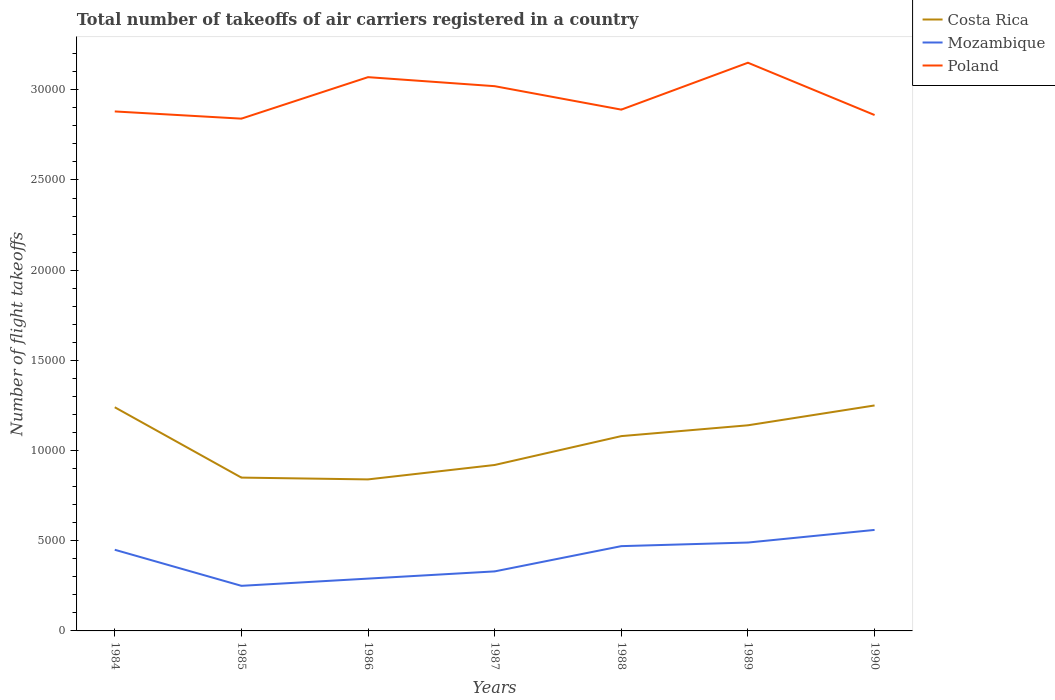Does the line corresponding to Poland intersect with the line corresponding to Mozambique?
Give a very brief answer. No. Is the number of lines equal to the number of legend labels?
Ensure brevity in your answer.  Yes. Across all years, what is the maximum total number of flight takeoffs in Costa Rica?
Give a very brief answer. 8400. In which year was the total number of flight takeoffs in Poland maximum?
Provide a short and direct response. 1985. What is the total total number of flight takeoffs in Costa Rica in the graph?
Offer a terse response. -4100. What is the difference between the highest and the second highest total number of flight takeoffs in Costa Rica?
Give a very brief answer. 4100. Is the total number of flight takeoffs in Mozambique strictly greater than the total number of flight takeoffs in Poland over the years?
Provide a succinct answer. Yes. How many years are there in the graph?
Your answer should be very brief. 7. Does the graph contain grids?
Your answer should be very brief. No. Where does the legend appear in the graph?
Offer a very short reply. Top right. What is the title of the graph?
Ensure brevity in your answer.  Total number of takeoffs of air carriers registered in a country. Does "Kazakhstan" appear as one of the legend labels in the graph?
Your answer should be very brief. No. What is the label or title of the Y-axis?
Ensure brevity in your answer.  Number of flight takeoffs. What is the Number of flight takeoffs of Costa Rica in 1984?
Offer a terse response. 1.24e+04. What is the Number of flight takeoffs in Mozambique in 1984?
Your response must be concise. 4500. What is the Number of flight takeoffs of Poland in 1984?
Provide a short and direct response. 2.88e+04. What is the Number of flight takeoffs in Costa Rica in 1985?
Make the answer very short. 8500. What is the Number of flight takeoffs in Mozambique in 1985?
Ensure brevity in your answer.  2500. What is the Number of flight takeoffs in Poland in 1985?
Your answer should be compact. 2.84e+04. What is the Number of flight takeoffs in Costa Rica in 1986?
Keep it short and to the point. 8400. What is the Number of flight takeoffs of Mozambique in 1986?
Your response must be concise. 2900. What is the Number of flight takeoffs in Poland in 1986?
Your answer should be compact. 3.07e+04. What is the Number of flight takeoffs of Costa Rica in 1987?
Offer a very short reply. 9200. What is the Number of flight takeoffs of Mozambique in 1987?
Your response must be concise. 3300. What is the Number of flight takeoffs in Poland in 1987?
Your answer should be compact. 3.02e+04. What is the Number of flight takeoffs in Costa Rica in 1988?
Provide a succinct answer. 1.08e+04. What is the Number of flight takeoffs of Mozambique in 1988?
Offer a terse response. 4700. What is the Number of flight takeoffs in Poland in 1988?
Your answer should be very brief. 2.89e+04. What is the Number of flight takeoffs in Costa Rica in 1989?
Offer a very short reply. 1.14e+04. What is the Number of flight takeoffs in Mozambique in 1989?
Your answer should be very brief. 4900. What is the Number of flight takeoffs of Poland in 1989?
Offer a terse response. 3.15e+04. What is the Number of flight takeoffs in Costa Rica in 1990?
Your answer should be very brief. 1.25e+04. What is the Number of flight takeoffs in Mozambique in 1990?
Keep it short and to the point. 5600. What is the Number of flight takeoffs of Poland in 1990?
Provide a short and direct response. 2.86e+04. Across all years, what is the maximum Number of flight takeoffs of Costa Rica?
Provide a short and direct response. 1.25e+04. Across all years, what is the maximum Number of flight takeoffs of Mozambique?
Your answer should be compact. 5600. Across all years, what is the maximum Number of flight takeoffs of Poland?
Ensure brevity in your answer.  3.15e+04. Across all years, what is the minimum Number of flight takeoffs of Costa Rica?
Keep it short and to the point. 8400. Across all years, what is the minimum Number of flight takeoffs in Mozambique?
Offer a terse response. 2500. Across all years, what is the minimum Number of flight takeoffs in Poland?
Provide a short and direct response. 2.84e+04. What is the total Number of flight takeoffs in Costa Rica in the graph?
Offer a terse response. 7.32e+04. What is the total Number of flight takeoffs of Mozambique in the graph?
Your answer should be compact. 2.84e+04. What is the total Number of flight takeoffs of Poland in the graph?
Offer a terse response. 2.07e+05. What is the difference between the Number of flight takeoffs of Costa Rica in 1984 and that in 1985?
Offer a terse response. 3900. What is the difference between the Number of flight takeoffs of Mozambique in 1984 and that in 1985?
Make the answer very short. 2000. What is the difference between the Number of flight takeoffs in Poland in 1984 and that in 1985?
Provide a short and direct response. 400. What is the difference between the Number of flight takeoffs of Costa Rica in 1984 and that in 1986?
Your answer should be compact. 4000. What is the difference between the Number of flight takeoffs of Mozambique in 1984 and that in 1986?
Provide a short and direct response. 1600. What is the difference between the Number of flight takeoffs in Poland in 1984 and that in 1986?
Offer a terse response. -1900. What is the difference between the Number of flight takeoffs in Costa Rica in 1984 and that in 1987?
Your answer should be very brief. 3200. What is the difference between the Number of flight takeoffs in Mozambique in 1984 and that in 1987?
Your response must be concise. 1200. What is the difference between the Number of flight takeoffs of Poland in 1984 and that in 1987?
Ensure brevity in your answer.  -1400. What is the difference between the Number of flight takeoffs in Costa Rica in 1984 and that in 1988?
Keep it short and to the point. 1600. What is the difference between the Number of flight takeoffs of Mozambique in 1984 and that in 1988?
Your answer should be very brief. -200. What is the difference between the Number of flight takeoffs of Poland in 1984 and that in 1988?
Keep it short and to the point. -100. What is the difference between the Number of flight takeoffs in Mozambique in 1984 and that in 1989?
Make the answer very short. -400. What is the difference between the Number of flight takeoffs of Poland in 1984 and that in 1989?
Keep it short and to the point. -2700. What is the difference between the Number of flight takeoffs of Costa Rica in 1984 and that in 1990?
Your answer should be very brief. -100. What is the difference between the Number of flight takeoffs of Mozambique in 1984 and that in 1990?
Provide a succinct answer. -1100. What is the difference between the Number of flight takeoffs in Poland in 1984 and that in 1990?
Provide a short and direct response. 200. What is the difference between the Number of flight takeoffs of Mozambique in 1985 and that in 1986?
Ensure brevity in your answer.  -400. What is the difference between the Number of flight takeoffs of Poland in 1985 and that in 1986?
Provide a succinct answer. -2300. What is the difference between the Number of flight takeoffs in Costa Rica in 1985 and that in 1987?
Your answer should be very brief. -700. What is the difference between the Number of flight takeoffs of Mozambique in 1985 and that in 1987?
Your answer should be compact. -800. What is the difference between the Number of flight takeoffs of Poland in 1985 and that in 1987?
Your response must be concise. -1800. What is the difference between the Number of flight takeoffs of Costa Rica in 1985 and that in 1988?
Offer a terse response. -2300. What is the difference between the Number of flight takeoffs of Mozambique in 1985 and that in 1988?
Offer a terse response. -2200. What is the difference between the Number of flight takeoffs of Poland in 1985 and that in 1988?
Give a very brief answer. -500. What is the difference between the Number of flight takeoffs of Costa Rica in 1985 and that in 1989?
Give a very brief answer. -2900. What is the difference between the Number of flight takeoffs in Mozambique in 1985 and that in 1989?
Your response must be concise. -2400. What is the difference between the Number of flight takeoffs in Poland in 1985 and that in 1989?
Ensure brevity in your answer.  -3100. What is the difference between the Number of flight takeoffs in Costa Rica in 1985 and that in 1990?
Your answer should be compact. -4000. What is the difference between the Number of flight takeoffs in Mozambique in 1985 and that in 1990?
Give a very brief answer. -3100. What is the difference between the Number of flight takeoffs of Poland in 1985 and that in 1990?
Offer a very short reply. -200. What is the difference between the Number of flight takeoffs in Costa Rica in 1986 and that in 1987?
Your response must be concise. -800. What is the difference between the Number of flight takeoffs of Mozambique in 1986 and that in 1987?
Offer a very short reply. -400. What is the difference between the Number of flight takeoffs of Costa Rica in 1986 and that in 1988?
Give a very brief answer. -2400. What is the difference between the Number of flight takeoffs in Mozambique in 1986 and that in 1988?
Make the answer very short. -1800. What is the difference between the Number of flight takeoffs in Poland in 1986 and that in 1988?
Provide a succinct answer. 1800. What is the difference between the Number of flight takeoffs in Costa Rica in 1986 and that in 1989?
Your answer should be very brief. -3000. What is the difference between the Number of flight takeoffs of Mozambique in 1986 and that in 1989?
Provide a succinct answer. -2000. What is the difference between the Number of flight takeoffs in Poland in 1986 and that in 1989?
Provide a short and direct response. -800. What is the difference between the Number of flight takeoffs in Costa Rica in 1986 and that in 1990?
Offer a very short reply. -4100. What is the difference between the Number of flight takeoffs in Mozambique in 1986 and that in 1990?
Provide a short and direct response. -2700. What is the difference between the Number of flight takeoffs of Poland in 1986 and that in 1990?
Provide a short and direct response. 2100. What is the difference between the Number of flight takeoffs of Costa Rica in 1987 and that in 1988?
Your answer should be compact. -1600. What is the difference between the Number of flight takeoffs of Mozambique in 1987 and that in 1988?
Ensure brevity in your answer.  -1400. What is the difference between the Number of flight takeoffs in Poland in 1987 and that in 1988?
Give a very brief answer. 1300. What is the difference between the Number of flight takeoffs of Costa Rica in 1987 and that in 1989?
Your response must be concise. -2200. What is the difference between the Number of flight takeoffs in Mozambique in 1987 and that in 1989?
Ensure brevity in your answer.  -1600. What is the difference between the Number of flight takeoffs in Poland in 1987 and that in 1989?
Your answer should be compact. -1300. What is the difference between the Number of flight takeoffs in Costa Rica in 1987 and that in 1990?
Your answer should be very brief. -3300. What is the difference between the Number of flight takeoffs of Mozambique in 1987 and that in 1990?
Provide a short and direct response. -2300. What is the difference between the Number of flight takeoffs in Poland in 1987 and that in 1990?
Offer a terse response. 1600. What is the difference between the Number of flight takeoffs of Costa Rica in 1988 and that in 1989?
Provide a short and direct response. -600. What is the difference between the Number of flight takeoffs of Mozambique in 1988 and that in 1989?
Offer a terse response. -200. What is the difference between the Number of flight takeoffs of Poland in 1988 and that in 1989?
Your answer should be compact. -2600. What is the difference between the Number of flight takeoffs in Costa Rica in 1988 and that in 1990?
Offer a terse response. -1700. What is the difference between the Number of flight takeoffs in Mozambique in 1988 and that in 1990?
Offer a terse response. -900. What is the difference between the Number of flight takeoffs of Poland in 1988 and that in 1990?
Make the answer very short. 300. What is the difference between the Number of flight takeoffs of Costa Rica in 1989 and that in 1990?
Your response must be concise. -1100. What is the difference between the Number of flight takeoffs in Mozambique in 1989 and that in 1990?
Offer a terse response. -700. What is the difference between the Number of flight takeoffs in Poland in 1989 and that in 1990?
Provide a short and direct response. 2900. What is the difference between the Number of flight takeoffs of Costa Rica in 1984 and the Number of flight takeoffs of Mozambique in 1985?
Your answer should be very brief. 9900. What is the difference between the Number of flight takeoffs in Costa Rica in 1984 and the Number of flight takeoffs in Poland in 1985?
Provide a short and direct response. -1.60e+04. What is the difference between the Number of flight takeoffs in Mozambique in 1984 and the Number of flight takeoffs in Poland in 1985?
Make the answer very short. -2.39e+04. What is the difference between the Number of flight takeoffs of Costa Rica in 1984 and the Number of flight takeoffs of Mozambique in 1986?
Provide a short and direct response. 9500. What is the difference between the Number of flight takeoffs in Costa Rica in 1984 and the Number of flight takeoffs in Poland in 1986?
Offer a very short reply. -1.83e+04. What is the difference between the Number of flight takeoffs in Mozambique in 1984 and the Number of flight takeoffs in Poland in 1986?
Offer a very short reply. -2.62e+04. What is the difference between the Number of flight takeoffs in Costa Rica in 1984 and the Number of flight takeoffs in Mozambique in 1987?
Keep it short and to the point. 9100. What is the difference between the Number of flight takeoffs in Costa Rica in 1984 and the Number of flight takeoffs in Poland in 1987?
Offer a very short reply. -1.78e+04. What is the difference between the Number of flight takeoffs of Mozambique in 1984 and the Number of flight takeoffs of Poland in 1987?
Your response must be concise. -2.57e+04. What is the difference between the Number of flight takeoffs of Costa Rica in 1984 and the Number of flight takeoffs of Mozambique in 1988?
Offer a very short reply. 7700. What is the difference between the Number of flight takeoffs of Costa Rica in 1984 and the Number of flight takeoffs of Poland in 1988?
Provide a short and direct response. -1.65e+04. What is the difference between the Number of flight takeoffs in Mozambique in 1984 and the Number of flight takeoffs in Poland in 1988?
Provide a short and direct response. -2.44e+04. What is the difference between the Number of flight takeoffs of Costa Rica in 1984 and the Number of flight takeoffs of Mozambique in 1989?
Offer a terse response. 7500. What is the difference between the Number of flight takeoffs of Costa Rica in 1984 and the Number of flight takeoffs of Poland in 1989?
Your answer should be compact. -1.91e+04. What is the difference between the Number of flight takeoffs in Mozambique in 1984 and the Number of flight takeoffs in Poland in 1989?
Your answer should be very brief. -2.70e+04. What is the difference between the Number of flight takeoffs of Costa Rica in 1984 and the Number of flight takeoffs of Mozambique in 1990?
Provide a short and direct response. 6800. What is the difference between the Number of flight takeoffs of Costa Rica in 1984 and the Number of flight takeoffs of Poland in 1990?
Offer a terse response. -1.62e+04. What is the difference between the Number of flight takeoffs of Mozambique in 1984 and the Number of flight takeoffs of Poland in 1990?
Provide a succinct answer. -2.41e+04. What is the difference between the Number of flight takeoffs in Costa Rica in 1985 and the Number of flight takeoffs in Mozambique in 1986?
Your answer should be very brief. 5600. What is the difference between the Number of flight takeoffs in Costa Rica in 1985 and the Number of flight takeoffs in Poland in 1986?
Make the answer very short. -2.22e+04. What is the difference between the Number of flight takeoffs in Mozambique in 1985 and the Number of flight takeoffs in Poland in 1986?
Offer a terse response. -2.82e+04. What is the difference between the Number of flight takeoffs in Costa Rica in 1985 and the Number of flight takeoffs in Mozambique in 1987?
Offer a very short reply. 5200. What is the difference between the Number of flight takeoffs in Costa Rica in 1985 and the Number of flight takeoffs in Poland in 1987?
Your answer should be very brief. -2.17e+04. What is the difference between the Number of flight takeoffs in Mozambique in 1985 and the Number of flight takeoffs in Poland in 1987?
Make the answer very short. -2.77e+04. What is the difference between the Number of flight takeoffs of Costa Rica in 1985 and the Number of flight takeoffs of Mozambique in 1988?
Your response must be concise. 3800. What is the difference between the Number of flight takeoffs of Costa Rica in 1985 and the Number of flight takeoffs of Poland in 1988?
Provide a short and direct response. -2.04e+04. What is the difference between the Number of flight takeoffs in Mozambique in 1985 and the Number of flight takeoffs in Poland in 1988?
Make the answer very short. -2.64e+04. What is the difference between the Number of flight takeoffs of Costa Rica in 1985 and the Number of flight takeoffs of Mozambique in 1989?
Your response must be concise. 3600. What is the difference between the Number of flight takeoffs of Costa Rica in 1985 and the Number of flight takeoffs of Poland in 1989?
Ensure brevity in your answer.  -2.30e+04. What is the difference between the Number of flight takeoffs of Mozambique in 1985 and the Number of flight takeoffs of Poland in 1989?
Your answer should be compact. -2.90e+04. What is the difference between the Number of flight takeoffs of Costa Rica in 1985 and the Number of flight takeoffs of Mozambique in 1990?
Provide a succinct answer. 2900. What is the difference between the Number of flight takeoffs in Costa Rica in 1985 and the Number of flight takeoffs in Poland in 1990?
Offer a terse response. -2.01e+04. What is the difference between the Number of flight takeoffs in Mozambique in 1985 and the Number of flight takeoffs in Poland in 1990?
Your answer should be compact. -2.61e+04. What is the difference between the Number of flight takeoffs of Costa Rica in 1986 and the Number of flight takeoffs of Mozambique in 1987?
Your answer should be very brief. 5100. What is the difference between the Number of flight takeoffs in Costa Rica in 1986 and the Number of flight takeoffs in Poland in 1987?
Offer a very short reply. -2.18e+04. What is the difference between the Number of flight takeoffs in Mozambique in 1986 and the Number of flight takeoffs in Poland in 1987?
Provide a short and direct response. -2.73e+04. What is the difference between the Number of flight takeoffs in Costa Rica in 1986 and the Number of flight takeoffs in Mozambique in 1988?
Make the answer very short. 3700. What is the difference between the Number of flight takeoffs of Costa Rica in 1986 and the Number of flight takeoffs of Poland in 1988?
Make the answer very short. -2.05e+04. What is the difference between the Number of flight takeoffs in Mozambique in 1986 and the Number of flight takeoffs in Poland in 1988?
Give a very brief answer. -2.60e+04. What is the difference between the Number of flight takeoffs in Costa Rica in 1986 and the Number of flight takeoffs in Mozambique in 1989?
Ensure brevity in your answer.  3500. What is the difference between the Number of flight takeoffs in Costa Rica in 1986 and the Number of flight takeoffs in Poland in 1989?
Offer a very short reply. -2.31e+04. What is the difference between the Number of flight takeoffs of Mozambique in 1986 and the Number of flight takeoffs of Poland in 1989?
Your response must be concise. -2.86e+04. What is the difference between the Number of flight takeoffs of Costa Rica in 1986 and the Number of flight takeoffs of Mozambique in 1990?
Ensure brevity in your answer.  2800. What is the difference between the Number of flight takeoffs of Costa Rica in 1986 and the Number of flight takeoffs of Poland in 1990?
Offer a very short reply. -2.02e+04. What is the difference between the Number of flight takeoffs in Mozambique in 1986 and the Number of flight takeoffs in Poland in 1990?
Give a very brief answer. -2.57e+04. What is the difference between the Number of flight takeoffs of Costa Rica in 1987 and the Number of flight takeoffs of Mozambique in 1988?
Give a very brief answer. 4500. What is the difference between the Number of flight takeoffs in Costa Rica in 1987 and the Number of flight takeoffs in Poland in 1988?
Offer a terse response. -1.97e+04. What is the difference between the Number of flight takeoffs of Mozambique in 1987 and the Number of flight takeoffs of Poland in 1988?
Your answer should be very brief. -2.56e+04. What is the difference between the Number of flight takeoffs in Costa Rica in 1987 and the Number of flight takeoffs in Mozambique in 1989?
Provide a succinct answer. 4300. What is the difference between the Number of flight takeoffs in Costa Rica in 1987 and the Number of flight takeoffs in Poland in 1989?
Offer a terse response. -2.23e+04. What is the difference between the Number of flight takeoffs of Mozambique in 1987 and the Number of flight takeoffs of Poland in 1989?
Provide a short and direct response. -2.82e+04. What is the difference between the Number of flight takeoffs of Costa Rica in 1987 and the Number of flight takeoffs of Mozambique in 1990?
Offer a very short reply. 3600. What is the difference between the Number of flight takeoffs in Costa Rica in 1987 and the Number of flight takeoffs in Poland in 1990?
Provide a succinct answer. -1.94e+04. What is the difference between the Number of flight takeoffs in Mozambique in 1987 and the Number of flight takeoffs in Poland in 1990?
Give a very brief answer. -2.53e+04. What is the difference between the Number of flight takeoffs of Costa Rica in 1988 and the Number of flight takeoffs of Mozambique in 1989?
Make the answer very short. 5900. What is the difference between the Number of flight takeoffs of Costa Rica in 1988 and the Number of flight takeoffs of Poland in 1989?
Give a very brief answer. -2.07e+04. What is the difference between the Number of flight takeoffs of Mozambique in 1988 and the Number of flight takeoffs of Poland in 1989?
Your response must be concise. -2.68e+04. What is the difference between the Number of flight takeoffs of Costa Rica in 1988 and the Number of flight takeoffs of Mozambique in 1990?
Offer a very short reply. 5200. What is the difference between the Number of flight takeoffs of Costa Rica in 1988 and the Number of flight takeoffs of Poland in 1990?
Your answer should be compact. -1.78e+04. What is the difference between the Number of flight takeoffs in Mozambique in 1988 and the Number of flight takeoffs in Poland in 1990?
Your answer should be very brief. -2.39e+04. What is the difference between the Number of flight takeoffs in Costa Rica in 1989 and the Number of flight takeoffs in Mozambique in 1990?
Offer a very short reply. 5800. What is the difference between the Number of flight takeoffs in Costa Rica in 1989 and the Number of flight takeoffs in Poland in 1990?
Your response must be concise. -1.72e+04. What is the difference between the Number of flight takeoffs of Mozambique in 1989 and the Number of flight takeoffs of Poland in 1990?
Offer a terse response. -2.37e+04. What is the average Number of flight takeoffs of Costa Rica per year?
Keep it short and to the point. 1.05e+04. What is the average Number of flight takeoffs of Mozambique per year?
Make the answer very short. 4057.14. What is the average Number of flight takeoffs in Poland per year?
Your answer should be compact. 2.96e+04. In the year 1984, what is the difference between the Number of flight takeoffs of Costa Rica and Number of flight takeoffs of Mozambique?
Your answer should be very brief. 7900. In the year 1984, what is the difference between the Number of flight takeoffs of Costa Rica and Number of flight takeoffs of Poland?
Provide a succinct answer. -1.64e+04. In the year 1984, what is the difference between the Number of flight takeoffs of Mozambique and Number of flight takeoffs of Poland?
Keep it short and to the point. -2.43e+04. In the year 1985, what is the difference between the Number of flight takeoffs in Costa Rica and Number of flight takeoffs in Mozambique?
Your answer should be very brief. 6000. In the year 1985, what is the difference between the Number of flight takeoffs of Costa Rica and Number of flight takeoffs of Poland?
Keep it short and to the point. -1.99e+04. In the year 1985, what is the difference between the Number of flight takeoffs of Mozambique and Number of flight takeoffs of Poland?
Offer a very short reply. -2.59e+04. In the year 1986, what is the difference between the Number of flight takeoffs of Costa Rica and Number of flight takeoffs of Mozambique?
Provide a succinct answer. 5500. In the year 1986, what is the difference between the Number of flight takeoffs of Costa Rica and Number of flight takeoffs of Poland?
Ensure brevity in your answer.  -2.23e+04. In the year 1986, what is the difference between the Number of flight takeoffs in Mozambique and Number of flight takeoffs in Poland?
Provide a short and direct response. -2.78e+04. In the year 1987, what is the difference between the Number of flight takeoffs in Costa Rica and Number of flight takeoffs in Mozambique?
Offer a very short reply. 5900. In the year 1987, what is the difference between the Number of flight takeoffs in Costa Rica and Number of flight takeoffs in Poland?
Provide a short and direct response. -2.10e+04. In the year 1987, what is the difference between the Number of flight takeoffs in Mozambique and Number of flight takeoffs in Poland?
Your answer should be compact. -2.69e+04. In the year 1988, what is the difference between the Number of flight takeoffs in Costa Rica and Number of flight takeoffs in Mozambique?
Make the answer very short. 6100. In the year 1988, what is the difference between the Number of flight takeoffs in Costa Rica and Number of flight takeoffs in Poland?
Keep it short and to the point. -1.81e+04. In the year 1988, what is the difference between the Number of flight takeoffs in Mozambique and Number of flight takeoffs in Poland?
Make the answer very short. -2.42e+04. In the year 1989, what is the difference between the Number of flight takeoffs in Costa Rica and Number of flight takeoffs in Mozambique?
Your answer should be very brief. 6500. In the year 1989, what is the difference between the Number of flight takeoffs of Costa Rica and Number of flight takeoffs of Poland?
Give a very brief answer. -2.01e+04. In the year 1989, what is the difference between the Number of flight takeoffs of Mozambique and Number of flight takeoffs of Poland?
Keep it short and to the point. -2.66e+04. In the year 1990, what is the difference between the Number of flight takeoffs of Costa Rica and Number of flight takeoffs of Mozambique?
Provide a short and direct response. 6900. In the year 1990, what is the difference between the Number of flight takeoffs in Costa Rica and Number of flight takeoffs in Poland?
Give a very brief answer. -1.61e+04. In the year 1990, what is the difference between the Number of flight takeoffs in Mozambique and Number of flight takeoffs in Poland?
Offer a terse response. -2.30e+04. What is the ratio of the Number of flight takeoffs in Costa Rica in 1984 to that in 1985?
Provide a succinct answer. 1.46. What is the ratio of the Number of flight takeoffs of Mozambique in 1984 to that in 1985?
Ensure brevity in your answer.  1.8. What is the ratio of the Number of flight takeoffs of Poland in 1984 to that in 1985?
Offer a terse response. 1.01. What is the ratio of the Number of flight takeoffs in Costa Rica in 1984 to that in 1986?
Keep it short and to the point. 1.48. What is the ratio of the Number of flight takeoffs of Mozambique in 1984 to that in 1986?
Your answer should be compact. 1.55. What is the ratio of the Number of flight takeoffs of Poland in 1984 to that in 1986?
Ensure brevity in your answer.  0.94. What is the ratio of the Number of flight takeoffs of Costa Rica in 1984 to that in 1987?
Give a very brief answer. 1.35. What is the ratio of the Number of flight takeoffs in Mozambique in 1984 to that in 1987?
Make the answer very short. 1.36. What is the ratio of the Number of flight takeoffs of Poland in 1984 to that in 1987?
Keep it short and to the point. 0.95. What is the ratio of the Number of flight takeoffs of Costa Rica in 1984 to that in 1988?
Provide a short and direct response. 1.15. What is the ratio of the Number of flight takeoffs of Mozambique in 1984 to that in 1988?
Ensure brevity in your answer.  0.96. What is the ratio of the Number of flight takeoffs in Costa Rica in 1984 to that in 1989?
Your response must be concise. 1.09. What is the ratio of the Number of flight takeoffs in Mozambique in 1984 to that in 1989?
Give a very brief answer. 0.92. What is the ratio of the Number of flight takeoffs of Poland in 1984 to that in 1989?
Your answer should be very brief. 0.91. What is the ratio of the Number of flight takeoffs in Mozambique in 1984 to that in 1990?
Make the answer very short. 0.8. What is the ratio of the Number of flight takeoffs of Poland in 1984 to that in 1990?
Keep it short and to the point. 1.01. What is the ratio of the Number of flight takeoffs of Costa Rica in 1985 to that in 1986?
Offer a very short reply. 1.01. What is the ratio of the Number of flight takeoffs of Mozambique in 1985 to that in 1986?
Your answer should be very brief. 0.86. What is the ratio of the Number of flight takeoffs of Poland in 1985 to that in 1986?
Offer a very short reply. 0.93. What is the ratio of the Number of flight takeoffs of Costa Rica in 1985 to that in 1987?
Your response must be concise. 0.92. What is the ratio of the Number of flight takeoffs in Mozambique in 1985 to that in 1987?
Make the answer very short. 0.76. What is the ratio of the Number of flight takeoffs of Poland in 1985 to that in 1987?
Offer a terse response. 0.94. What is the ratio of the Number of flight takeoffs of Costa Rica in 1985 to that in 1988?
Ensure brevity in your answer.  0.79. What is the ratio of the Number of flight takeoffs of Mozambique in 1985 to that in 1988?
Provide a short and direct response. 0.53. What is the ratio of the Number of flight takeoffs of Poland in 1985 to that in 1988?
Ensure brevity in your answer.  0.98. What is the ratio of the Number of flight takeoffs in Costa Rica in 1985 to that in 1989?
Give a very brief answer. 0.75. What is the ratio of the Number of flight takeoffs of Mozambique in 1985 to that in 1989?
Your response must be concise. 0.51. What is the ratio of the Number of flight takeoffs of Poland in 1985 to that in 1989?
Give a very brief answer. 0.9. What is the ratio of the Number of flight takeoffs in Costa Rica in 1985 to that in 1990?
Keep it short and to the point. 0.68. What is the ratio of the Number of flight takeoffs in Mozambique in 1985 to that in 1990?
Your answer should be compact. 0.45. What is the ratio of the Number of flight takeoffs of Mozambique in 1986 to that in 1987?
Your response must be concise. 0.88. What is the ratio of the Number of flight takeoffs of Poland in 1986 to that in 1987?
Give a very brief answer. 1.02. What is the ratio of the Number of flight takeoffs of Costa Rica in 1986 to that in 1988?
Your response must be concise. 0.78. What is the ratio of the Number of flight takeoffs of Mozambique in 1986 to that in 1988?
Make the answer very short. 0.62. What is the ratio of the Number of flight takeoffs of Poland in 1986 to that in 1988?
Make the answer very short. 1.06. What is the ratio of the Number of flight takeoffs of Costa Rica in 1986 to that in 1989?
Offer a terse response. 0.74. What is the ratio of the Number of flight takeoffs in Mozambique in 1986 to that in 1989?
Provide a short and direct response. 0.59. What is the ratio of the Number of flight takeoffs in Poland in 1986 to that in 1989?
Your answer should be compact. 0.97. What is the ratio of the Number of flight takeoffs in Costa Rica in 1986 to that in 1990?
Keep it short and to the point. 0.67. What is the ratio of the Number of flight takeoffs in Mozambique in 1986 to that in 1990?
Offer a very short reply. 0.52. What is the ratio of the Number of flight takeoffs of Poland in 1986 to that in 1990?
Keep it short and to the point. 1.07. What is the ratio of the Number of flight takeoffs of Costa Rica in 1987 to that in 1988?
Ensure brevity in your answer.  0.85. What is the ratio of the Number of flight takeoffs in Mozambique in 1987 to that in 1988?
Ensure brevity in your answer.  0.7. What is the ratio of the Number of flight takeoffs in Poland in 1987 to that in 1988?
Keep it short and to the point. 1.04. What is the ratio of the Number of flight takeoffs in Costa Rica in 1987 to that in 1989?
Make the answer very short. 0.81. What is the ratio of the Number of flight takeoffs of Mozambique in 1987 to that in 1989?
Give a very brief answer. 0.67. What is the ratio of the Number of flight takeoffs of Poland in 1987 to that in 1989?
Your response must be concise. 0.96. What is the ratio of the Number of flight takeoffs of Costa Rica in 1987 to that in 1990?
Provide a succinct answer. 0.74. What is the ratio of the Number of flight takeoffs of Mozambique in 1987 to that in 1990?
Give a very brief answer. 0.59. What is the ratio of the Number of flight takeoffs of Poland in 1987 to that in 1990?
Ensure brevity in your answer.  1.06. What is the ratio of the Number of flight takeoffs in Mozambique in 1988 to that in 1989?
Keep it short and to the point. 0.96. What is the ratio of the Number of flight takeoffs of Poland in 1988 to that in 1989?
Make the answer very short. 0.92. What is the ratio of the Number of flight takeoffs of Costa Rica in 1988 to that in 1990?
Your answer should be compact. 0.86. What is the ratio of the Number of flight takeoffs of Mozambique in 1988 to that in 1990?
Provide a succinct answer. 0.84. What is the ratio of the Number of flight takeoffs in Poland in 1988 to that in 1990?
Make the answer very short. 1.01. What is the ratio of the Number of flight takeoffs of Costa Rica in 1989 to that in 1990?
Provide a succinct answer. 0.91. What is the ratio of the Number of flight takeoffs in Mozambique in 1989 to that in 1990?
Ensure brevity in your answer.  0.88. What is the ratio of the Number of flight takeoffs in Poland in 1989 to that in 1990?
Provide a succinct answer. 1.1. What is the difference between the highest and the second highest Number of flight takeoffs in Mozambique?
Keep it short and to the point. 700. What is the difference between the highest and the second highest Number of flight takeoffs of Poland?
Your response must be concise. 800. What is the difference between the highest and the lowest Number of flight takeoffs in Costa Rica?
Give a very brief answer. 4100. What is the difference between the highest and the lowest Number of flight takeoffs in Mozambique?
Offer a very short reply. 3100. What is the difference between the highest and the lowest Number of flight takeoffs of Poland?
Ensure brevity in your answer.  3100. 